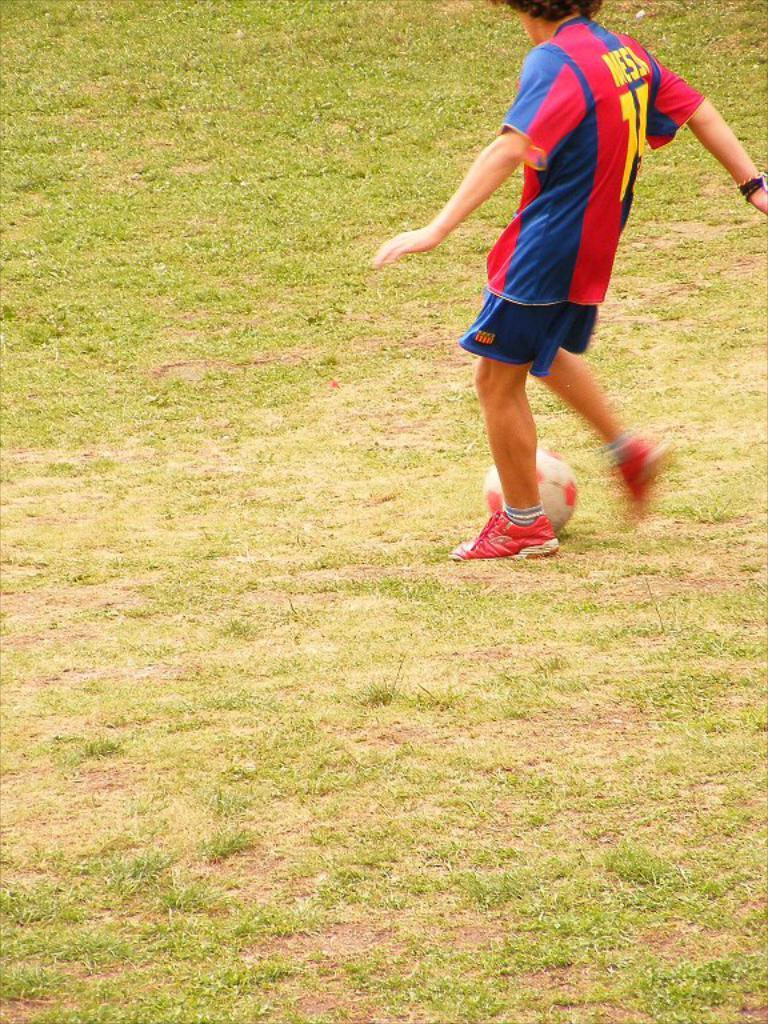Provide a one-sentence caption for the provided image. Man wearing a number 71 jersey kicking a soccer ball on a grassy field. 